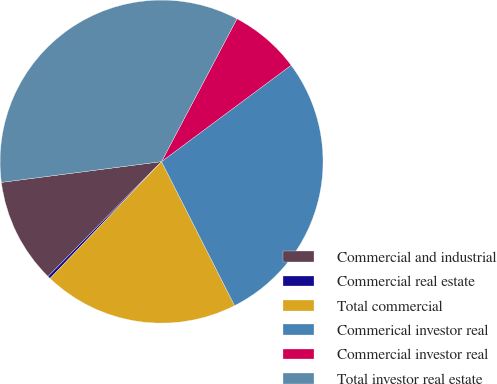Convert chart. <chart><loc_0><loc_0><loc_500><loc_500><pie_chart><fcel>Commercial and industrial<fcel>Commercial real estate<fcel>Total commercial<fcel>Commerical investor real<fcel>Commercial investor real<fcel>Total investor real estate<nl><fcel>10.54%<fcel>0.28%<fcel>19.6%<fcel>27.7%<fcel>7.09%<fcel>34.79%<nl></chart> 